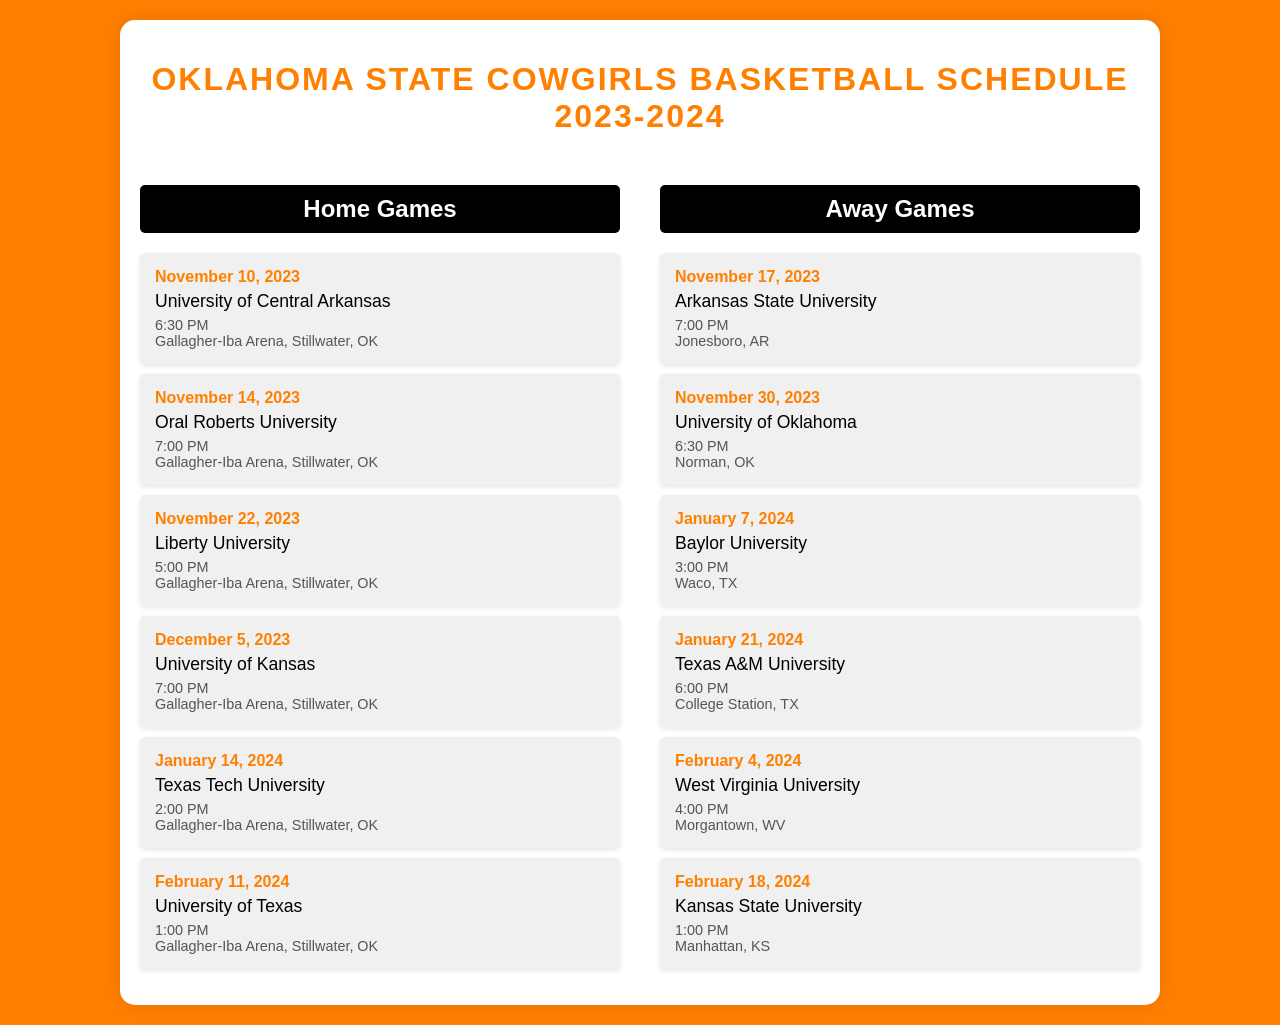What date do the Cowgirls play their first home game? The first home game is on November 10, 2023, against the University of Central Arkansas.
Answer: November 10, 2023 What time is the game against the University of Kansas? The game against the University of Kansas is scheduled for 7:00 PM.
Answer: 7:00 PM Where is the game against Texas A&M University held? The game against Texas A&M University will be played in College Station, TX.
Answer: College Station, TX How many home games are listed in the schedule? There are six home games shown in the schedule.
Answer: Six What is the last home game of the season? The last home game listed in the schedule is against the University of Texas on February 11, 2024.
Answer: February 11, 2024 Which team do the Cowgirls face on January 21, 2024? On January 21, 2024, the Cowgirls are facing Texas A&M University.
Answer: Texas A&M University What is the location of the away game on February 4, 2024? The away game on February 4, 2024, is at Morgantown, WV.
Answer: Morgantown, WV When do the Cowgirls play the University of Oklahoma? The Cowgirls play the University of Oklahoma on November 30, 2023.
Answer: November 30, 2023 What opponent are the Cowgirls playing when they first play at home? The opponent for their first home game is the University of Central Arkansas.
Answer: University of Central Arkansas 